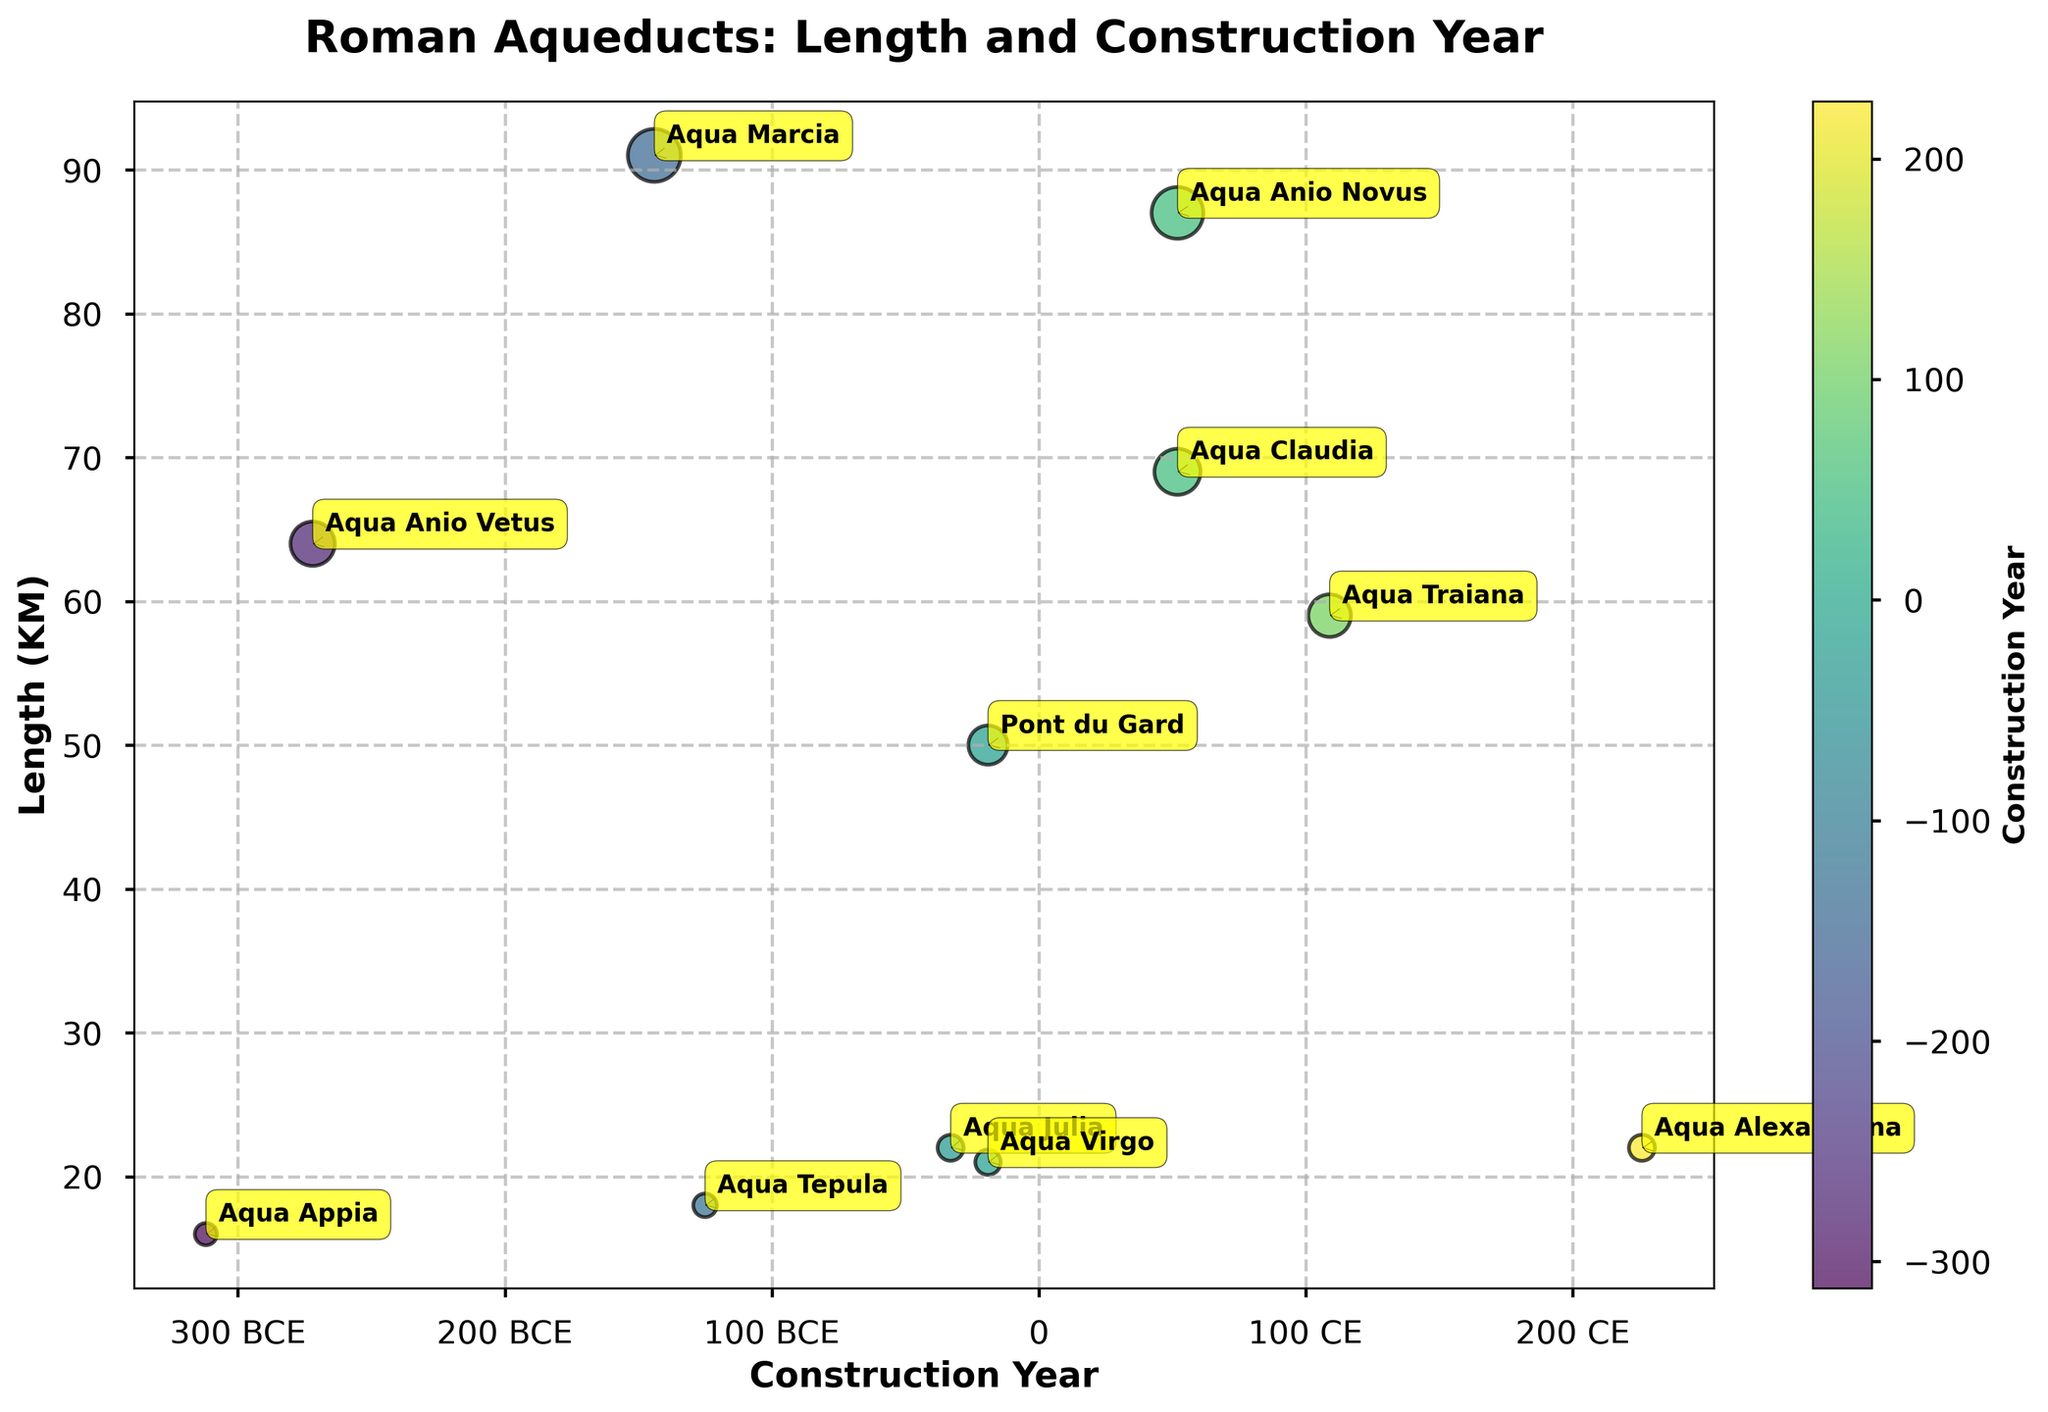What is the title of the figure? The title of the figure is usually located at the top of the plot. In this case, the title is evident and clear.
Answer: "Roman Aqueducts: Length and Construction Year" What are the labels for the x-axis and y-axis? Axis labels indicate what each axis represents. The x-axis label indicates the construction year, and the y-axis label indicates the aqueduct length in kilometers.
Answer: "Construction Year" and "Length (KM)" How many aqueducts are represented in the plot? Count the number of bubbles, each representing an aqueduct. There are 11 distinct bubbles in the plot.
Answer: 11 Which aqueduct was constructed most recently? The most recent aqueduct would have the highest year value on the x-axis. Aqua Alexandrina, constructed in Rome in 226 CE, is the most recent.
Answer: Aqua Alexandrina What is the range of aqueduct lengths shown in the plot? Find the shortest and longest aqueduct. The plot shows lengths ranging from 16 KM (Aqua Appia) to 91 KM (Aqua Marcia).
Answer: 16 KM to 91 KM Which two aqueducts were completed in the year 52 CE and how do their lengths compare? Look for bubbles annotated with the year 52 CE and compare their y-axis values. Aqua Claudia (69 KM) and Aqua Anio Novus (87 KM) were built in 52 CE. Aqua Anio Novus is longer.
Answer: Aqua Claudia (69 KM) and Aqua Anio Novus (87 KM); Aqua Anio Novus is longer Which aqueduct has the smallest size bubble and what is its length? The bubble size corresponds to the length of the aqueduct, with smaller bubbles indicating shorter lengths. Aqua Appia has the smallest bubble with a length of 16 KM.
Answer: Aqua Appia, 16 KM In which century BCE were the majority of the aqueducts represented in the plot built? Analyze the distribution of aqueduct names and construction years in BCE. The majority of the aqueducts were constructed in the 3rd century BCE.
Answer: 3rd century BCE What is the average length of all the aqueducts constructed in BCE? Sum the lengths of aqueducts built in BCE and divide by the number of those aqueducts. (16 + 64 + 91 + 18 + 22 + 21 + 50) / 7 = 282 / 7.
Answer: 40.3 KM How does the length of Pont du Gard compare to the lengths of aqueducts built in Rome? Identify the length of Pont du Gard (50 KM) and compare it to aqueducts in Rome. Most Roman aqueducts are longer except Aqua Tepula (18 KM), Aqua Julia (22 KM), Aqua Virgo (21 KM), Aqua Appia (16 KM).
Answer: Pont du Gard (50 KM) is longer than Aqua Tepula, Aqua Julia, Aqua Virgo, and Aqua Appia and shorter than most others 